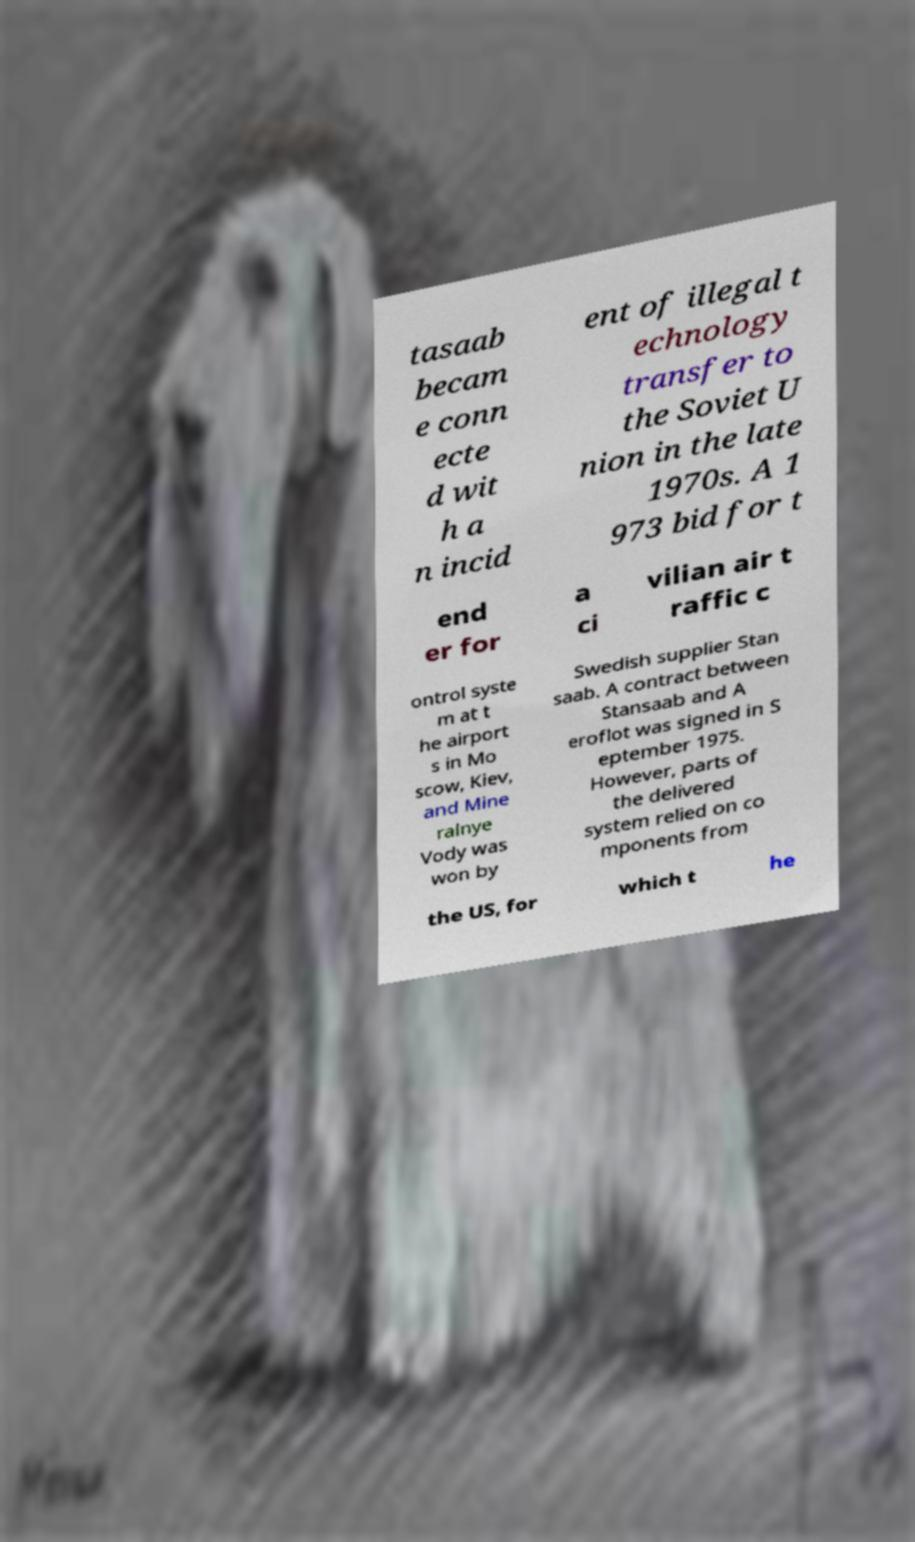There's text embedded in this image that I need extracted. Can you transcribe it verbatim? tasaab becam e conn ecte d wit h a n incid ent of illegal t echnology transfer to the Soviet U nion in the late 1970s. A 1 973 bid for t end er for a ci vilian air t raffic c ontrol syste m at t he airport s in Mo scow, Kiev, and Mine ralnye Vody was won by Swedish supplier Stan saab. A contract between Stansaab and A eroflot was signed in S eptember 1975. However, parts of the delivered system relied on co mponents from the US, for which t he 